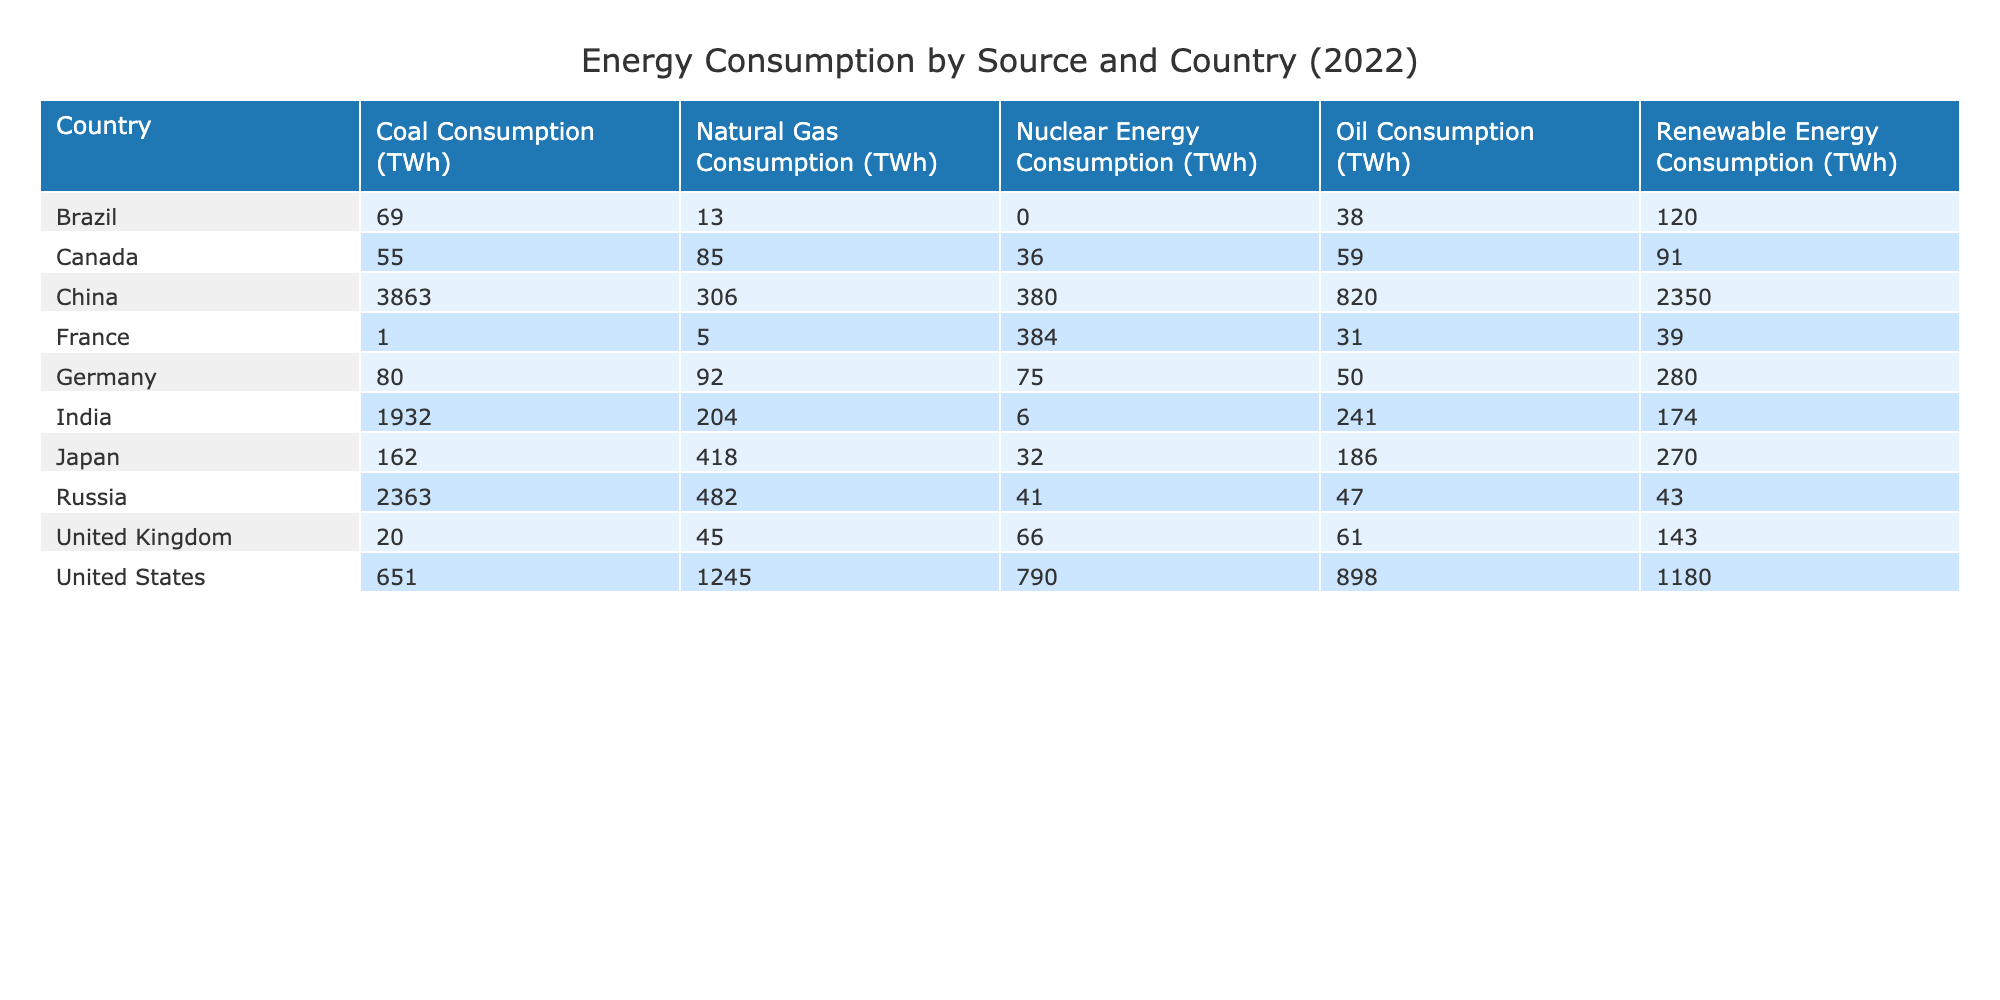What is the coal consumption of China? The table shows the coal consumption for each country, with China listed. Under the "Coal Consumption (TWh)" column, the value for China is highlighted, allowing retrieval of this specific data point.
Answer: 3863 Which country has the highest nuclear energy consumption? To determine this, we look at the "Nuclear Energy Consumption (TWh)" column. By scanning through the values for each country, we see that the highest value corresponds to France. A simple comparison reveals France has 384 TWh, which is greater than any other country's value in the same column.
Answer: France What is the total consumption of renewable energy for the United States and Germany combined? For this, we look at the "Renewable Energy Consumption (TWh)" column. The United States has 1180 TWh and Germany has 280 TWh. Adding these values together: 1180 + 280 = 1460 TWh provides the total combined consumption.
Answer: 1460 Is Russia's oil consumption greater than Germany's? The question can be answered by comparing the "Oil Consumption (TWh)" values for both countries. For Russia, the value is 47 TWh, while for Germany, it is 50 TWh. Since 47 is less than 50, the answer indicates that Russia's oil consumption is not greater.
Answer: No What is the average natural gas consumption for the listed countries? To find the average natural gas consumption, we sum all values in the "Natural Gas Consumption (TWh)" column which are: 1245 (USA) + 306 (China) + 92 (Germany) + 204 (India) + 45 (UK) + 5 (France) + 13 (Brazil) + 482 (Russia) + 418 (Japan) + 85 (Canada) = 2895 TWh. Since there are 10 countries, we divide by 10 to find the average: 2895 / 10 = 289.5 TWh.
Answer: 289.5 Which country has the lowest oil consumption? To identify the country with the lowest oil consumption, we refer to the "Oil Consumption (TWh)" column and check the values listed for all countries. Scanning through the values shows that Brazil has the lowest consumption at 38 TWh.
Answer: Brazil 